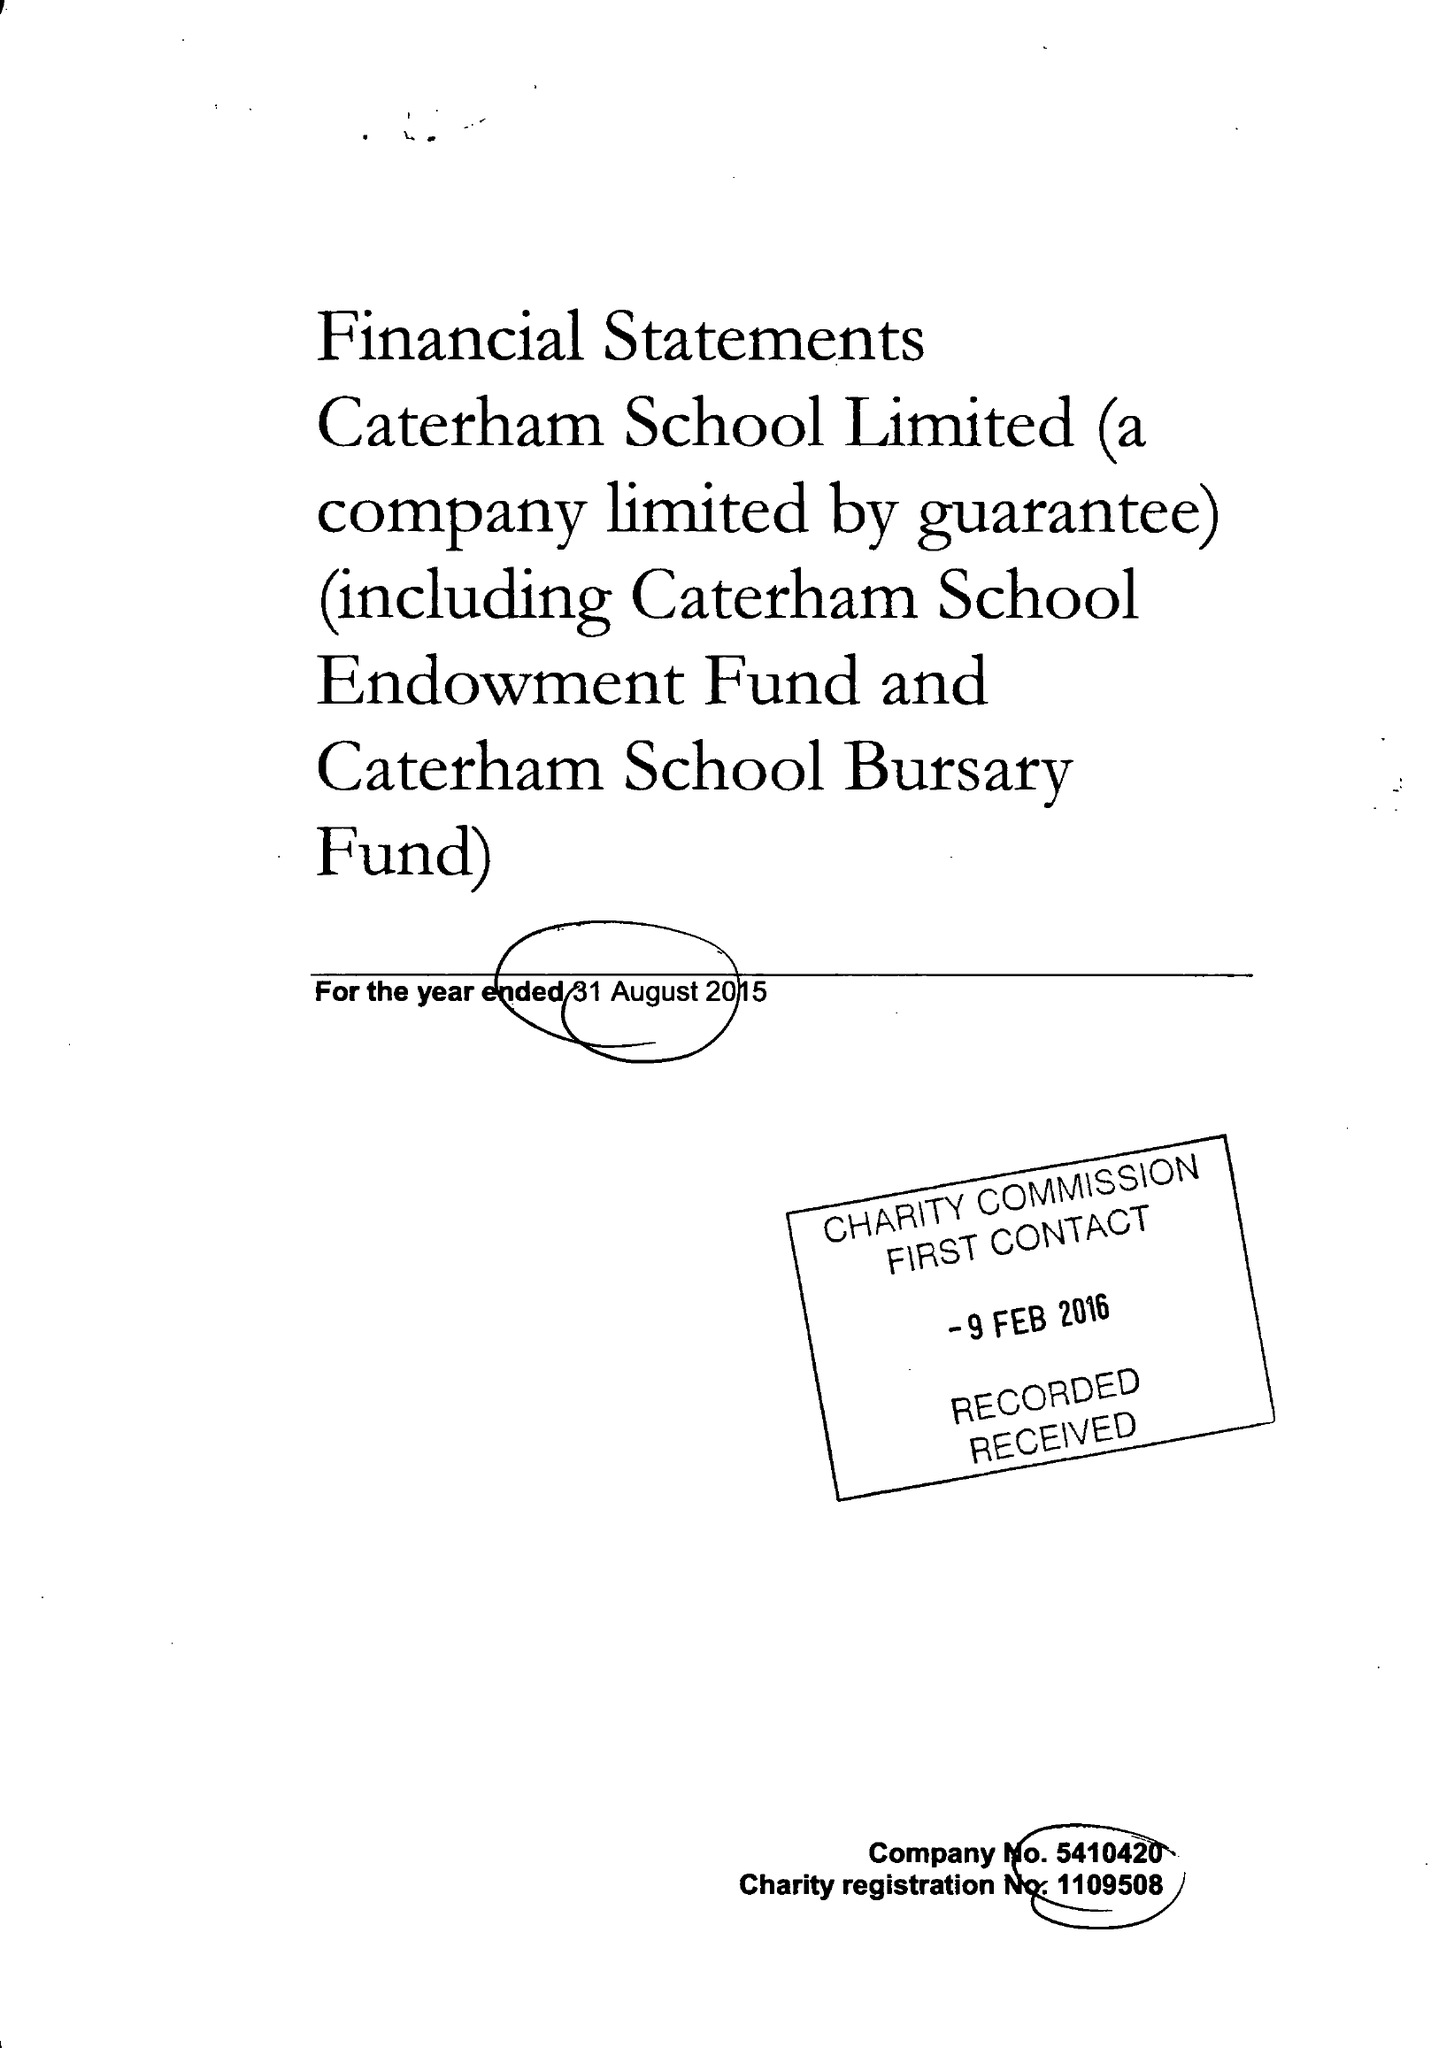What is the value for the address__postcode?
Answer the question using a single word or phrase. CR3 6YA 